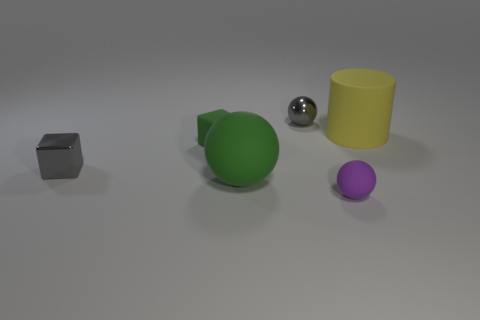Subtract all matte spheres. How many spheres are left? 1 Add 3 small yellow rubber cubes. How many objects exist? 9 Subtract all yellow balls. Subtract all blue cylinders. How many balls are left? 3 Subtract all cylinders. How many objects are left? 5 Subtract all large yellow rubber things. Subtract all metal spheres. How many objects are left? 4 Add 3 large yellow objects. How many large yellow objects are left? 4 Add 4 yellow rubber things. How many yellow rubber things exist? 5 Subtract 0 purple cylinders. How many objects are left? 6 